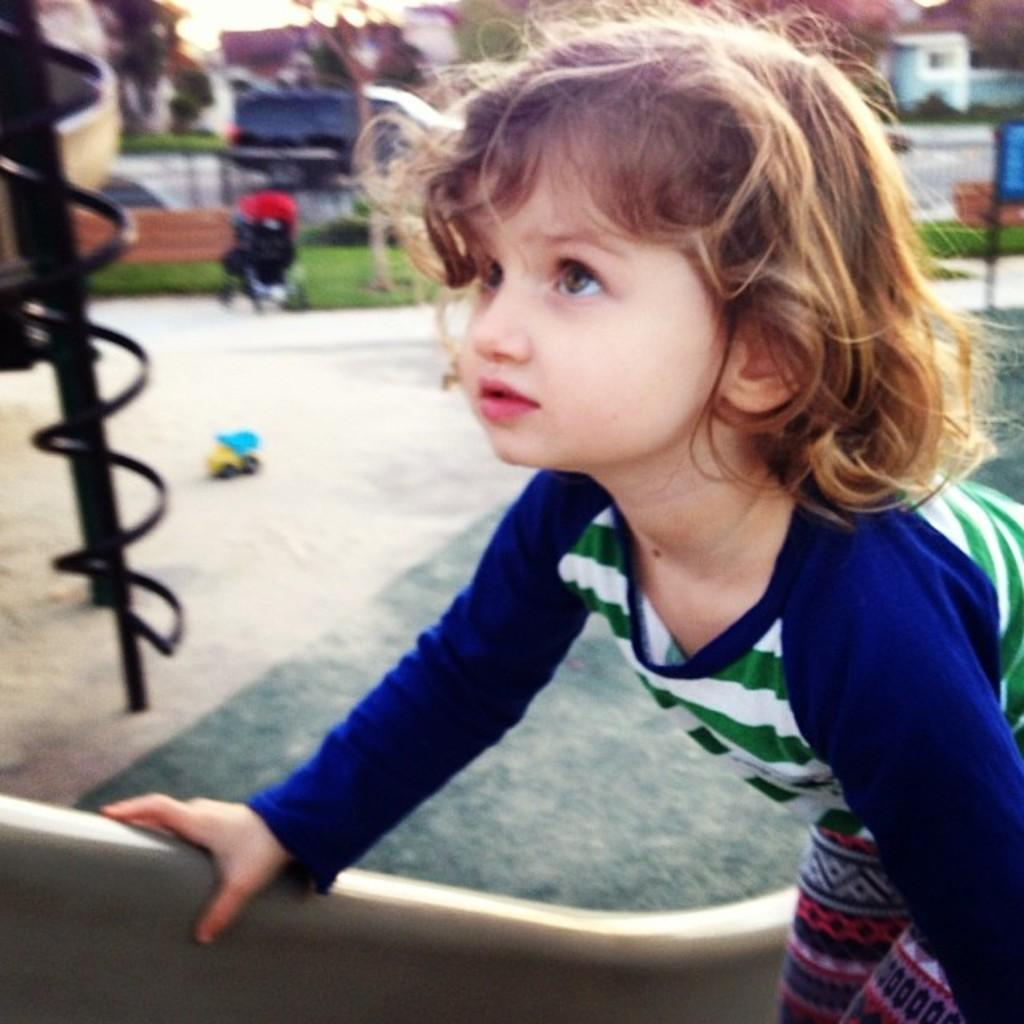Who is the main subject in the image? There is a small girl in the image. What is the girl doing in the image? The girl is on a slide. Where is the slide located in the image? The slide is on the right side of the image. What can be seen in the background of the image? There are buildings and trees in the background of the image. What decision does the boy make in the image? There is no boy present in the image; it features a small girl on a slide. 